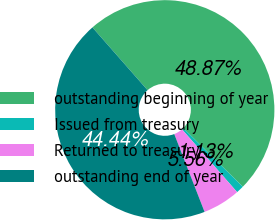Convert chart. <chart><loc_0><loc_0><loc_500><loc_500><pie_chart><fcel>outstanding beginning of year<fcel>Issued from treasury<fcel>Returned to treasury<fcel>outstanding end of year<nl><fcel>48.87%<fcel>1.13%<fcel>5.56%<fcel>44.44%<nl></chart> 